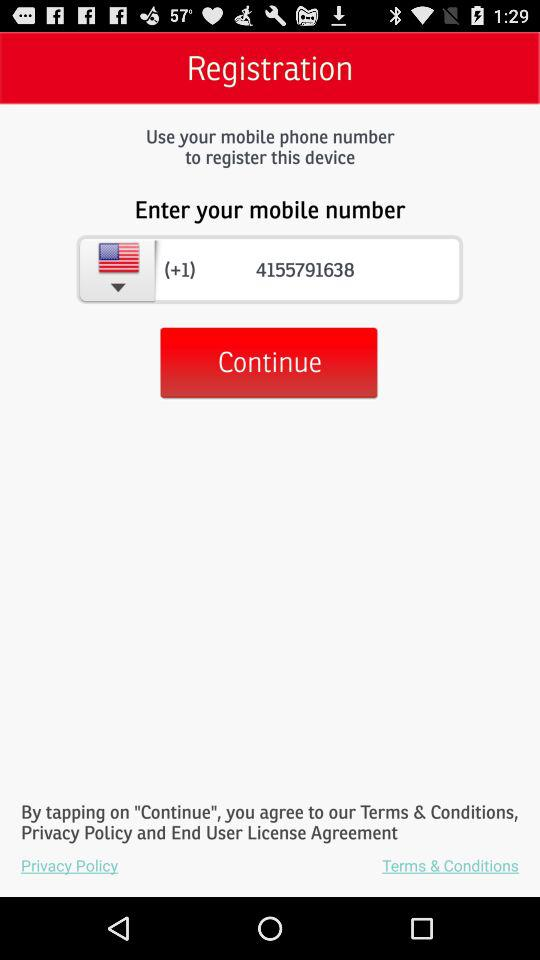Can you tell me what terms and policies are linked at the bottom of the page? The image includes links to the Privacy Policy and Terms & Conditions at the bottom of the registration screen, which the user agrees to by tapping 'Continue'. 